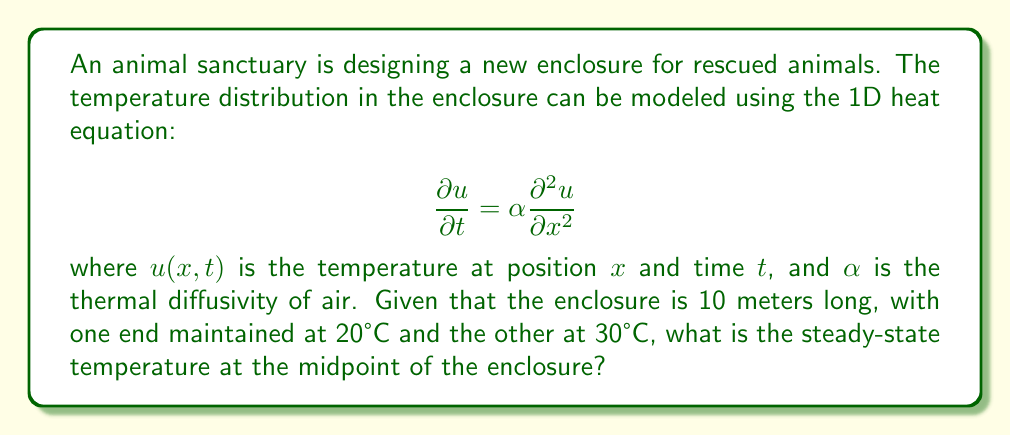Solve this math problem. To solve this problem, we need to follow these steps:

1) For the steady-state solution, the temperature doesn't change with time, so $\frac{\partial u}{\partial t} = 0$. This reduces our heat equation to:

   $$0 = \alpha \frac{\partial^2 u}{\partial x^2}$$

2) Integrating twice with respect to $x$:

   $$u(x) = Ax + B$$

   where $A$ and $B$ are constants to be determined from the boundary conditions.

3) We have the following boundary conditions:
   - At $x = 0$, $u(0) = 20°C$
   - At $x = 10$, $u(10) = 30°C$

4) Applying these conditions:
   
   $u(0) = B = 20$
   $u(10) = 10A + 20 = 30$

5) Solving for $A$:

   $10A = 10$
   $A = 1$

6) Therefore, our steady-state temperature distribution is:

   $$u(x) = x + 20$$

7) The midpoint of the enclosure is at $x = 5$ meters. To find the temperature here, we substitute this into our equation:

   $$u(5) = 5 + 20 = 25$$

Thus, the steady-state temperature at the midpoint of the enclosure is 25°C.
Answer: 25°C 